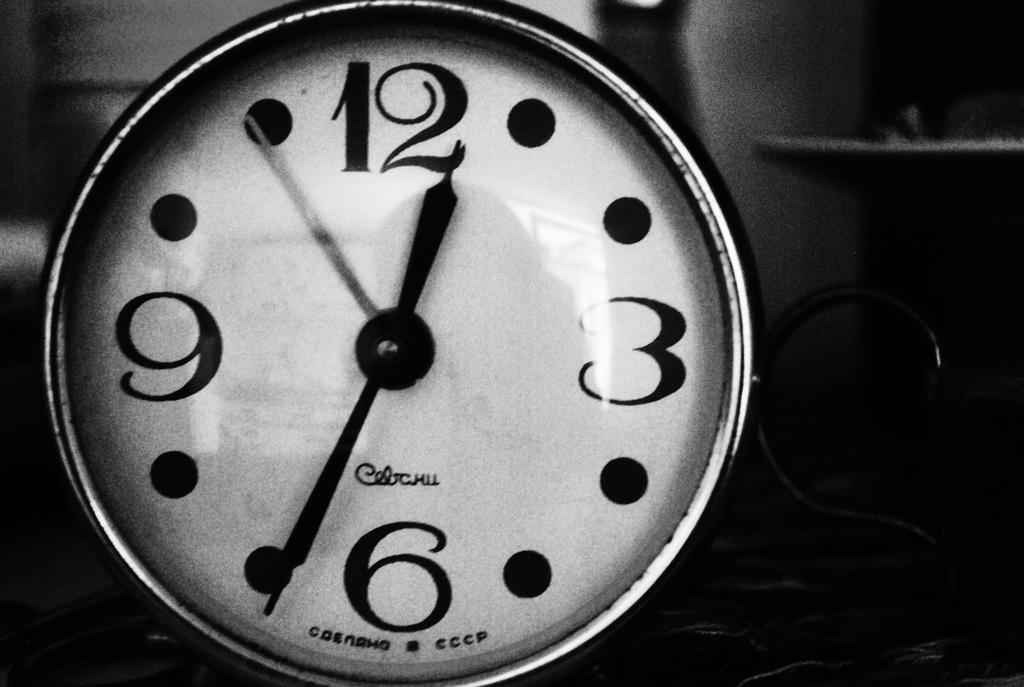<image>
Give a short and clear explanation of the subsequent image. A white black and metal alarm clock whose time is twelve thirty four. 